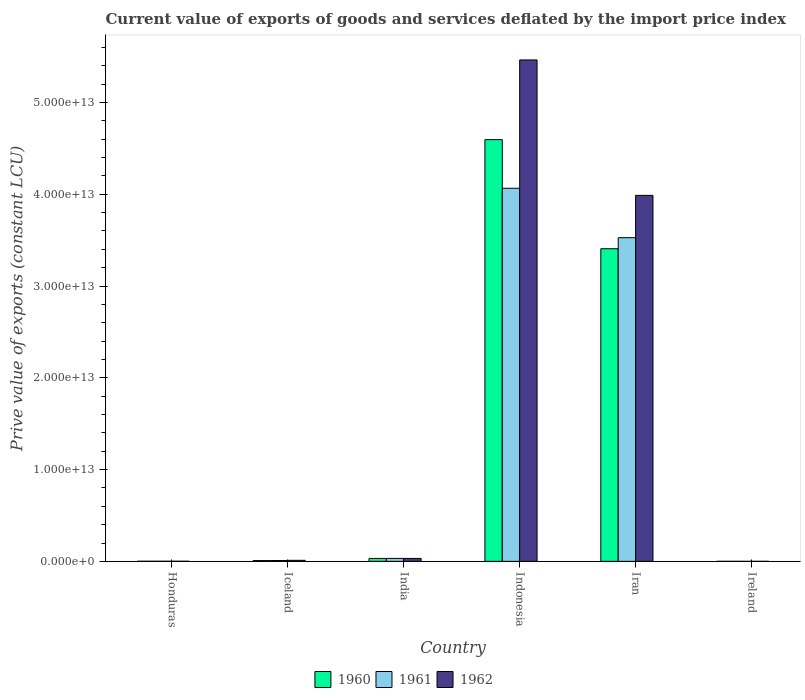How many bars are there on the 6th tick from the left?
Ensure brevity in your answer.  3. In how many cases, is the number of bars for a given country not equal to the number of legend labels?
Offer a very short reply. 0. What is the prive value of exports in 1960 in Iran?
Give a very brief answer. 3.41e+13. Across all countries, what is the maximum prive value of exports in 1962?
Offer a terse response. 5.46e+13. Across all countries, what is the minimum prive value of exports in 1960?
Provide a short and direct response. 2.78e+09. In which country was the prive value of exports in 1961 maximum?
Your answer should be compact. Indonesia. In which country was the prive value of exports in 1961 minimum?
Offer a very short reply. Ireland. What is the total prive value of exports in 1962 in the graph?
Offer a very short reply. 9.50e+13. What is the difference between the prive value of exports in 1960 in Honduras and that in Ireland?
Offer a very short reply. 7.89e+09. What is the difference between the prive value of exports in 1960 in Iceland and the prive value of exports in 1962 in Ireland?
Your response must be concise. 8.28e+1. What is the average prive value of exports in 1962 per country?
Offer a very short reply. 1.58e+13. What is the difference between the prive value of exports of/in 1960 and prive value of exports of/in 1961 in Honduras?
Your answer should be compact. -1.27e+09. In how many countries, is the prive value of exports in 1960 greater than 28000000000000 LCU?
Ensure brevity in your answer.  2. What is the ratio of the prive value of exports in 1962 in Iceland to that in Iran?
Make the answer very short. 0. Is the difference between the prive value of exports in 1960 in Honduras and Iceland greater than the difference between the prive value of exports in 1961 in Honduras and Iceland?
Keep it short and to the point. Yes. What is the difference between the highest and the second highest prive value of exports in 1961?
Make the answer very short. 4.03e+13. What is the difference between the highest and the lowest prive value of exports in 1962?
Make the answer very short. 5.46e+13. What does the 3rd bar from the right in Ireland represents?
Provide a succinct answer. 1960. How many bars are there?
Provide a succinct answer. 18. What is the difference between two consecutive major ticks on the Y-axis?
Keep it short and to the point. 1.00e+13. Are the values on the major ticks of Y-axis written in scientific E-notation?
Ensure brevity in your answer.  Yes. Does the graph contain any zero values?
Your response must be concise. No. How many legend labels are there?
Your answer should be compact. 3. How are the legend labels stacked?
Offer a very short reply. Horizontal. What is the title of the graph?
Offer a terse response. Current value of exports of goods and services deflated by the import price index. Does "1998" appear as one of the legend labels in the graph?
Offer a very short reply. No. What is the label or title of the X-axis?
Your response must be concise. Country. What is the label or title of the Y-axis?
Your answer should be compact. Prive value of exports (constant LCU). What is the Prive value of exports (constant LCU) in 1960 in Honduras?
Your answer should be very brief. 1.07e+1. What is the Prive value of exports (constant LCU) of 1961 in Honduras?
Give a very brief answer. 1.19e+1. What is the Prive value of exports (constant LCU) of 1962 in Honduras?
Make the answer very short. 1.31e+1. What is the Prive value of exports (constant LCU) in 1960 in Iceland?
Offer a terse response. 8.60e+1. What is the Prive value of exports (constant LCU) of 1961 in Iceland?
Offer a very short reply. 9.34e+1. What is the Prive value of exports (constant LCU) in 1962 in Iceland?
Offer a very short reply. 1.12e+11. What is the Prive value of exports (constant LCU) in 1960 in India?
Provide a short and direct response. 3.21e+11. What is the Prive value of exports (constant LCU) of 1961 in India?
Keep it short and to the point. 3.20e+11. What is the Prive value of exports (constant LCU) of 1962 in India?
Your answer should be compact. 3.19e+11. What is the Prive value of exports (constant LCU) in 1960 in Indonesia?
Offer a terse response. 4.60e+13. What is the Prive value of exports (constant LCU) in 1961 in Indonesia?
Offer a very short reply. 4.07e+13. What is the Prive value of exports (constant LCU) of 1962 in Indonesia?
Your answer should be very brief. 5.46e+13. What is the Prive value of exports (constant LCU) in 1960 in Iran?
Your answer should be very brief. 3.41e+13. What is the Prive value of exports (constant LCU) of 1961 in Iran?
Offer a terse response. 3.53e+13. What is the Prive value of exports (constant LCU) in 1962 in Iran?
Provide a short and direct response. 3.99e+13. What is the Prive value of exports (constant LCU) of 1960 in Ireland?
Keep it short and to the point. 2.78e+09. What is the Prive value of exports (constant LCU) of 1961 in Ireland?
Make the answer very short. 3.22e+09. What is the Prive value of exports (constant LCU) of 1962 in Ireland?
Offer a very short reply. 3.23e+09. Across all countries, what is the maximum Prive value of exports (constant LCU) in 1960?
Your answer should be compact. 4.60e+13. Across all countries, what is the maximum Prive value of exports (constant LCU) of 1961?
Offer a very short reply. 4.07e+13. Across all countries, what is the maximum Prive value of exports (constant LCU) in 1962?
Ensure brevity in your answer.  5.46e+13. Across all countries, what is the minimum Prive value of exports (constant LCU) of 1960?
Offer a terse response. 2.78e+09. Across all countries, what is the minimum Prive value of exports (constant LCU) of 1961?
Offer a terse response. 3.22e+09. Across all countries, what is the minimum Prive value of exports (constant LCU) in 1962?
Ensure brevity in your answer.  3.23e+09. What is the total Prive value of exports (constant LCU) in 1960 in the graph?
Your answer should be very brief. 8.04e+13. What is the total Prive value of exports (constant LCU) of 1961 in the graph?
Provide a succinct answer. 7.63e+13. What is the total Prive value of exports (constant LCU) in 1962 in the graph?
Your response must be concise. 9.50e+13. What is the difference between the Prive value of exports (constant LCU) of 1960 in Honduras and that in Iceland?
Provide a succinct answer. -7.54e+1. What is the difference between the Prive value of exports (constant LCU) of 1961 in Honduras and that in Iceland?
Your answer should be very brief. -8.14e+1. What is the difference between the Prive value of exports (constant LCU) of 1962 in Honduras and that in Iceland?
Your answer should be very brief. -9.94e+1. What is the difference between the Prive value of exports (constant LCU) of 1960 in Honduras and that in India?
Provide a short and direct response. -3.10e+11. What is the difference between the Prive value of exports (constant LCU) of 1961 in Honduras and that in India?
Provide a succinct answer. -3.08e+11. What is the difference between the Prive value of exports (constant LCU) of 1962 in Honduras and that in India?
Your answer should be very brief. -3.05e+11. What is the difference between the Prive value of exports (constant LCU) of 1960 in Honduras and that in Indonesia?
Your response must be concise. -4.59e+13. What is the difference between the Prive value of exports (constant LCU) of 1961 in Honduras and that in Indonesia?
Offer a terse response. -4.06e+13. What is the difference between the Prive value of exports (constant LCU) of 1962 in Honduras and that in Indonesia?
Provide a short and direct response. -5.46e+13. What is the difference between the Prive value of exports (constant LCU) of 1960 in Honduras and that in Iran?
Make the answer very short. -3.41e+13. What is the difference between the Prive value of exports (constant LCU) in 1961 in Honduras and that in Iran?
Your answer should be compact. -3.53e+13. What is the difference between the Prive value of exports (constant LCU) of 1962 in Honduras and that in Iran?
Give a very brief answer. -3.99e+13. What is the difference between the Prive value of exports (constant LCU) of 1960 in Honduras and that in Ireland?
Give a very brief answer. 7.89e+09. What is the difference between the Prive value of exports (constant LCU) of 1961 in Honduras and that in Ireland?
Keep it short and to the point. 8.72e+09. What is the difference between the Prive value of exports (constant LCU) of 1962 in Honduras and that in Ireland?
Provide a succinct answer. 9.87e+09. What is the difference between the Prive value of exports (constant LCU) of 1960 in Iceland and that in India?
Provide a succinct answer. -2.35e+11. What is the difference between the Prive value of exports (constant LCU) of 1961 in Iceland and that in India?
Provide a short and direct response. -2.27e+11. What is the difference between the Prive value of exports (constant LCU) of 1962 in Iceland and that in India?
Provide a short and direct response. -2.06e+11. What is the difference between the Prive value of exports (constant LCU) in 1960 in Iceland and that in Indonesia?
Provide a succinct answer. -4.59e+13. What is the difference between the Prive value of exports (constant LCU) in 1961 in Iceland and that in Indonesia?
Offer a terse response. -4.06e+13. What is the difference between the Prive value of exports (constant LCU) in 1962 in Iceland and that in Indonesia?
Keep it short and to the point. -5.45e+13. What is the difference between the Prive value of exports (constant LCU) in 1960 in Iceland and that in Iran?
Provide a short and direct response. -3.40e+13. What is the difference between the Prive value of exports (constant LCU) of 1961 in Iceland and that in Iran?
Give a very brief answer. -3.52e+13. What is the difference between the Prive value of exports (constant LCU) of 1962 in Iceland and that in Iran?
Make the answer very short. -3.98e+13. What is the difference between the Prive value of exports (constant LCU) in 1960 in Iceland and that in Ireland?
Give a very brief answer. 8.33e+1. What is the difference between the Prive value of exports (constant LCU) of 1961 in Iceland and that in Ireland?
Keep it short and to the point. 9.02e+1. What is the difference between the Prive value of exports (constant LCU) in 1962 in Iceland and that in Ireland?
Provide a short and direct response. 1.09e+11. What is the difference between the Prive value of exports (constant LCU) in 1960 in India and that in Indonesia?
Keep it short and to the point. -4.56e+13. What is the difference between the Prive value of exports (constant LCU) in 1961 in India and that in Indonesia?
Ensure brevity in your answer.  -4.03e+13. What is the difference between the Prive value of exports (constant LCU) in 1962 in India and that in Indonesia?
Offer a terse response. -5.43e+13. What is the difference between the Prive value of exports (constant LCU) in 1960 in India and that in Iran?
Keep it short and to the point. -3.37e+13. What is the difference between the Prive value of exports (constant LCU) of 1961 in India and that in Iran?
Provide a short and direct response. -3.49e+13. What is the difference between the Prive value of exports (constant LCU) of 1962 in India and that in Iran?
Your answer should be very brief. -3.96e+13. What is the difference between the Prive value of exports (constant LCU) of 1960 in India and that in Ireland?
Provide a short and direct response. 3.18e+11. What is the difference between the Prive value of exports (constant LCU) of 1961 in India and that in Ireland?
Your answer should be very brief. 3.17e+11. What is the difference between the Prive value of exports (constant LCU) in 1962 in India and that in Ireland?
Provide a short and direct response. 3.15e+11. What is the difference between the Prive value of exports (constant LCU) in 1960 in Indonesia and that in Iran?
Keep it short and to the point. 1.19e+13. What is the difference between the Prive value of exports (constant LCU) of 1961 in Indonesia and that in Iran?
Ensure brevity in your answer.  5.38e+12. What is the difference between the Prive value of exports (constant LCU) of 1962 in Indonesia and that in Iran?
Make the answer very short. 1.48e+13. What is the difference between the Prive value of exports (constant LCU) in 1960 in Indonesia and that in Ireland?
Give a very brief answer. 4.59e+13. What is the difference between the Prive value of exports (constant LCU) of 1961 in Indonesia and that in Ireland?
Your answer should be very brief. 4.06e+13. What is the difference between the Prive value of exports (constant LCU) of 1962 in Indonesia and that in Ireland?
Your response must be concise. 5.46e+13. What is the difference between the Prive value of exports (constant LCU) of 1960 in Iran and that in Ireland?
Offer a very short reply. 3.41e+13. What is the difference between the Prive value of exports (constant LCU) in 1961 in Iran and that in Ireland?
Provide a succinct answer. 3.53e+13. What is the difference between the Prive value of exports (constant LCU) of 1962 in Iran and that in Ireland?
Give a very brief answer. 3.99e+13. What is the difference between the Prive value of exports (constant LCU) in 1960 in Honduras and the Prive value of exports (constant LCU) in 1961 in Iceland?
Your answer should be compact. -8.27e+1. What is the difference between the Prive value of exports (constant LCU) in 1960 in Honduras and the Prive value of exports (constant LCU) in 1962 in Iceland?
Give a very brief answer. -1.02e+11. What is the difference between the Prive value of exports (constant LCU) of 1961 in Honduras and the Prive value of exports (constant LCU) of 1962 in Iceland?
Your answer should be very brief. -1.01e+11. What is the difference between the Prive value of exports (constant LCU) in 1960 in Honduras and the Prive value of exports (constant LCU) in 1961 in India?
Offer a very short reply. -3.10e+11. What is the difference between the Prive value of exports (constant LCU) of 1960 in Honduras and the Prive value of exports (constant LCU) of 1962 in India?
Give a very brief answer. -3.08e+11. What is the difference between the Prive value of exports (constant LCU) in 1961 in Honduras and the Prive value of exports (constant LCU) in 1962 in India?
Keep it short and to the point. -3.07e+11. What is the difference between the Prive value of exports (constant LCU) of 1960 in Honduras and the Prive value of exports (constant LCU) of 1961 in Indonesia?
Your answer should be very brief. -4.06e+13. What is the difference between the Prive value of exports (constant LCU) of 1960 in Honduras and the Prive value of exports (constant LCU) of 1962 in Indonesia?
Ensure brevity in your answer.  -5.46e+13. What is the difference between the Prive value of exports (constant LCU) in 1961 in Honduras and the Prive value of exports (constant LCU) in 1962 in Indonesia?
Give a very brief answer. -5.46e+13. What is the difference between the Prive value of exports (constant LCU) in 1960 in Honduras and the Prive value of exports (constant LCU) in 1961 in Iran?
Give a very brief answer. -3.53e+13. What is the difference between the Prive value of exports (constant LCU) in 1960 in Honduras and the Prive value of exports (constant LCU) in 1962 in Iran?
Give a very brief answer. -3.99e+13. What is the difference between the Prive value of exports (constant LCU) of 1961 in Honduras and the Prive value of exports (constant LCU) of 1962 in Iran?
Provide a succinct answer. -3.99e+13. What is the difference between the Prive value of exports (constant LCU) in 1960 in Honduras and the Prive value of exports (constant LCU) in 1961 in Ireland?
Give a very brief answer. 7.45e+09. What is the difference between the Prive value of exports (constant LCU) in 1960 in Honduras and the Prive value of exports (constant LCU) in 1962 in Ireland?
Offer a terse response. 7.44e+09. What is the difference between the Prive value of exports (constant LCU) in 1961 in Honduras and the Prive value of exports (constant LCU) in 1962 in Ireland?
Keep it short and to the point. 8.71e+09. What is the difference between the Prive value of exports (constant LCU) of 1960 in Iceland and the Prive value of exports (constant LCU) of 1961 in India?
Make the answer very short. -2.34e+11. What is the difference between the Prive value of exports (constant LCU) of 1960 in Iceland and the Prive value of exports (constant LCU) of 1962 in India?
Ensure brevity in your answer.  -2.32e+11. What is the difference between the Prive value of exports (constant LCU) in 1961 in Iceland and the Prive value of exports (constant LCU) in 1962 in India?
Keep it short and to the point. -2.25e+11. What is the difference between the Prive value of exports (constant LCU) in 1960 in Iceland and the Prive value of exports (constant LCU) in 1961 in Indonesia?
Give a very brief answer. -4.06e+13. What is the difference between the Prive value of exports (constant LCU) of 1960 in Iceland and the Prive value of exports (constant LCU) of 1962 in Indonesia?
Ensure brevity in your answer.  -5.45e+13. What is the difference between the Prive value of exports (constant LCU) of 1961 in Iceland and the Prive value of exports (constant LCU) of 1962 in Indonesia?
Ensure brevity in your answer.  -5.45e+13. What is the difference between the Prive value of exports (constant LCU) in 1960 in Iceland and the Prive value of exports (constant LCU) in 1961 in Iran?
Offer a terse response. -3.52e+13. What is the difference between the Prive value of exports (constant LCU) of 1960 in Iceland and the Prive value of exports (constant LCU) of 1962 in Iran?
Provide a short and direct response. -3.98e+13. What is the difference between the Prive value of exports (constant LCU) of 1961 in Iceland and the Prive value of exports (constant LCU) of 1962 in Iran?
Give a very brief answer. -3.98e+13. What is the difference between the Prive value of exports (constant LCU) of 1960 in Iceland and the Prive value of exports (constant LCU) of 1961 in Ireland?
Your response must be concise. 8.28e+1. What is the difference between the Prive value of exports (constant LCU) of 1960 in Iceland and the Prive value of exports (constant LCU) of 1962 in Ireland?
Your answer should be very brief. 8.28e+1. What is the difference between the Prive value of exports (constant LCU) of 1961 in Iceland and the Prive value of exports (constant LCU) of 1962 in Ireland?
Ensure brevity in your answer.  9.02e+1. What is the difference between the Prive value of exports (constant LCU) of 1960 in India and the Prive value of exports (constant LCU) of 1961 in Indonesia?
Offer a very short reply. -4.03e+13. What is the difference between the Prive value of exports (constant LCU) in 1960 in India and the Prive value of exports (constant LCU) in 1962 in Indonesia?
Make the answer very short. -5.43e+13. What is the difference between the Prive value of exports (constant LCU) of 1961 in India and the Prive value of exports (constant LCU) of 1962 in Indonesia?
Your answer should be compact. -5.43e+13. What is the difference between the Prive value of exports (constant LCU) of 1960 in India and the Prive value of exports (constant LCU) of 1961 in Iran?
Make the answer very short. -3.49e+13. What is the difference between the Prive value of exports (constant LCU) of 1960 in India and the Prive value of exports (constant LCU) of 1962 in Iran?
Your response must be concise. -3.96e+13. What is the difference between the Prive value of exports (constant LCU) in 1961 in India and the Prive value of exports (constant LCU) in 1962 in Iran?
Your response must be concise. -3.96e+13. What is the difference between the Prive value of exports (constant LCU) in 1960 in India and the Prive value of exports (constant LCU) in 1961 in Ireland?
Your response must be concise. 3.18e+11. What is the difference between the Prive value of exports (constant LCU) in 1960 in India and the Prive value of exports (constant LCU) in 1962 in Ireland?
Keep it short and to the point. 3.18e+11. What is the difference between the Prive value of exports (constant LCU) in 1961 in India and the Prive value of exports (constant LCU) in 1962 in Ireland?
Keep it short and to the point. 3.17e+11. What is the difference between the Prive value of exports (constant LCU) of 1960 in Indonesia and the Prive value of exports (constant LCU) of 1961 in Iran?
Ensure brevity in your answer.  1.07e+13. What is the difference between the Prive value of exports (constant LCU) in 1960 in Indonesia and the Prive value of exports (constant LCU) in 1962 in Iran?
Keep it short and to the point. 6.07e+12. What is the difference between the Prive value of exports (constant LCU) in 1961 in Indonesia and the Prive value of exports (constant LCU) in 1962 in Iran?
Give a very brief answer. 7.73e+11. What is the difference between the Prive value of exports (constant LCU) of 1960 in Indonesia and the Prive value of exports (constant LCU) of 1961 in Ireland?
Your answer should be very brief. 4.59e+13. What is the difference between the Prive value of exports (constant LCU) of 1960 in Indonesia and the Prive value of exports (constant LCU) of 1962 in Ireland?
Keep it short and to the point. 4.59e+13. What is the difference between the Prive value of exports (constant LCU) in 1961 in Indonesia and the Prive value of exports (constant LCU) in 1962 in Ireland?
Your response must be concise. 4.06e+13. What is the difference between the Prive value of exports (constant LCU) of 1960 in Iran and the Prive value of exports (constant LCU) of 1961 in Ireland?
Ensure brevity in your answer.  3.41e+13. What is the difference between the Prive value of exports (constant LCU) in 1960 in Iran and the Prive value of exports (constant LCU) in 1962 in Ireland?
Keep it short and to the point. 3.41e+13. What is the difference between the Prive value of exports (constant LCU) of 1961 in Iran and the Prive value of exports (constant LCU) of 1962 in Ireland?
Give a very brief answer. 3.53e+13. What is the average Prive value of exports (constant LCU) in 1960 per country?
Give a very brief answer. 1.34e+13. What is the average Prive value of exports (constant LCU) of 1961 per country?
Offer a terse response. 1.27e+13. What is the average Prive value of exports (constant LCU) in 1962 per country?
Give a very brief answer. 1.58e+13. What is the difference between the Prive value of exports (constant LCU) of 1960 and Prive value of exports (constant LCU) of 1961 in Honduras?
Provide a succinct answer. -1.27e+09. What is the difference between the Prive value of exports (constant LCU) of 1960 and Prive value of exports (constant LCU) of 1962 in Honduras?
Your answer should be compact. -2.43e+09. What is the difference between the Prive value of exports (constant LCU) in 1961 and Prive value of exports (constant LCU) in 1962 in Honduras?
Offer a terse response. -1.15e+09. What is the difference between the Prive value of exports (constant LCU) of 1960 and Prive value of exports (constant LCU) of 1961 in Iceland?
Keep it short and to the point. -7.34e+09. What is the difference between the Prive value of exports (constant LCU) in 1960 and Prive value of exports (constant LCU) in 1962 in Iceland?
Your answer should be very brief. -2.64e+1. What is the difference between the Prive value of exports (constant LCU) of 1961 and Prive value of exports (constant LCU) of 1962 in Iceland?
Make the answer very short. -1.91e+1. What is the difference between the Prive value of exports (constant LCU) of 1960 and Prive value of exports (constant LCU) of 1961 in India?
Ensure brevity in your answer.  5.97e+08. What is the difference between the Prive value of exports (constant LCU) of 1960 and Prive value of exports (constant LCU) of 1962 in India?
Keep it short and to the point. 2.45e+09. What is the difference between the Prive value of exports (constant LCU) of 1961 and Prive value of exports (constant LCU) of 1962 in India?
Provide a short and direct response. 1.86e+09. What is the difference between the Prive value of exports (constant LCU) of 1960 and Prive value of exports (constant LCU) of 1961 in Indonesia?
Your answer should be compact. 5.30e+12. What is the difference between the Prive value of exports (constant LCU) in 1960 and Prive value of exports (constant LCU) in 1962 in Indonesia?
Your response must be concise. -8.68e+12. What is the difference between the Prive value of exports (constant LCU) in 1961 and Prive value of exports (constant LCU) in 1962 in Indonesia?
Make the answer very short. -1.40e+13. What is the difference between the Prive value of exports (constant LCU) of 1960 and Prive value of exports (constant LCU) of 1961 in Iran?
Provide a short and direct response. -1.21e+12. What is the difference between the Prive value of exports (constant LCU) of 1960 and Prive value of exports (constant LCU) of 1962 in Iran?
Your response must be concise. -5.81e+12. What is the difference between the Prive value of exports (constant LCU) of 1961 and Prive value of exports (constant LCU) of 1962 in Iran?
Keep it short and to the point. -4.61e+12. What is the difference between the Prive value of exports (constant LCU) of 1960 and Prive value of exports (constant LCU) of 1961 in Ireland?
Give a very brief answer. -4.39e+08. What is the difference between the Prive value of exports (constant LCU) of 1960 and Prive value of exports (constant LCU) of 1962 in Ireland?
Provide a succinct answer. -4.49e+08. What is the difference between the Prive value of exports (constant LCU) in 1961 and Prive value of exports (constant LCU) in 1962 in Ireland?
Your answer should be compact. -9.94e+06. What is the ratio of the Prive value of exports (constant LCU) in 1960 in Honduras to that in Iceland?
Provide a short and direct response. 0.12. What is the ratio of the Prive value of exports (constant LCU) of 1961 in Honduras to that in Iceland?
Provide a succinct answer. 0.13. What is the ratio of the Prive value of exports (constant LCU) in 1962 in Honduras to that in Iceland?
Give a very brief answer. 0.12. What is the ratio of the Prive value of exports (constant LCU) of 1960 in Honduras to that in India?
Your response must be concise. 0.03. What is the ratio of the Prive value of exports (constant LCU) of 1961 in Honduras to that in India?
Provide a succinct answer. 0.04. What is the ratio of the Prive value of exports (constant LCU) of 1962 in Honduras to that in India?
Give a very brief answer. 0.04. What is the ratio of the Prive value of exports (constant LCU) of 1960 in Honduras to that in Indonesia?
Provide a succinct answer. 0. What is the ratio of the Prive value of exports (constant LCU) in 1960 in Honduras to that in Iran?
Ensure brevity in your answer.  0. What is the ratio of the Prive value of exports (constant LCU) of 1960 in Honduras to that in Ireland?
Offer a terse response. 3.84. What is the ratio of the Prive value of exports (constant LCU) in 1961 in Honduras to that in Ireland?
Offer a terse response. 3.71. What is the ratio of the Prive value of exports (constant LCU) of 1962 in Honduras to that in Ireland?
Provide a succinct answer. 4.06. What is the ratio of the Prive value of exports (constant LCU) in 1960 in Iceland to that in India?
Offer a very short reply. 0.27. What is the ratio of the Prive value of exports (constant LCU) in 1961 in Iceland to that in India?
Keep it short and to the point. 0.29. What is the ratio of the Prive value of exports (constant LCU) in 1962 in Iceland to that in India?
Provide a short and direct response. 0.35. What is the ratio of the Prive value of exports (constant LCU) in 1960 in Iceland to that in Indonesia?
Keep it short and to the point. 0. What is the ratio of the Prive value of exports (constant LCU) in 1961 in Iceland to that in Indonesia?
Provide a succinct answer. 0. What is the ratio of the Prive value of exports (constant LCU) of 1962 in Iceland to that in Indonesia?
Offer a terse response. 0. What is the ratio of the Prive value of exports (constant LCU) of 1960 in Iceland to that in Iran?
Ensure brevity in your answer.  0. What is the ratio of the Prive value of exports (constant LCU) of 1961 in Iceland to that in Iran?
Your answer should be very brief. 0. What is the ratio of the Prive value of exports (constant LCU) of 1962 in Iceland to that in Iran?
Make the answer very short. 0. What is the ratio of the Prive value of exports (constant LCU) of 1960 in Iceland to that in Ireland?
Your answer should be compact. 30.98. What is the ratio of the Prive value of exports (constant LCU) of 1961 in Iceland to that in Ireland?
Your answer should be compact. 29.03. What is the ratio of the Prive value of exports (constant LCU) in 1962 in Iceland to that in Ireland?
Provide a succinct answer. 34.86. What is the ratio of the Prive value of exports (constant LCU) in 1960 in India to that in Indonesia?
Make the answer very short. 0.01. What is the ratio of the Prive value of exports (constant LCU) of 1961 in India to that in Indonesia?
Give a very brief answer. 0.01. What is the ratio of the Prive value of exports (constant LCU) of 1962 in India to that in Indonesia?
Offer a terse response. 0.01. What is the ratio of the Prive value of exports (constant LCU) in 1960 in India to that in Iran?
Give a very brief answer. 0.01. What is the ratio of the Prive value of exports (constant LCU) of 1961 in India to that in Iran?
Give a very brief answer. 0.01. What is the ratio of the Prive value of exports (constant LCU) in 1962 in India to that in Iran?
Offer a terse response. 0.01. What is the ratio of the Prive value of exports (constant LCU) of 1960 in India to that in Ireland?
Offer a very short reply. 115.58. What is the ratio of the Prive value of exports (constant LCU) of 1961 in India to that in Ireland?
Offer a very short reply. 99.61. What is the ratio of the Prive value of exports (constant LCU) in 1962 in India to that in Ireland?
Keep it short and to the point. 98.73. What is the ratio of the Prive value of exports (constant LCU) in 1960 in Indonesia to that in Iran?
Ensure brevity in your answer.  1.35. What is the ratio of the Prive value of exports (constant LCU) of 1961 in Indonesia to that in Iran?
Your answer should be compact. 1.15. What is the ratio of the Prive value of exports (constant LCU) of 1962 in Indonesia to that in Iran?
Give a very brief answer. 1.37. What is the ratio of the Prive value of exports (constant LCU) of 1960 in Indonesia to that in Ireland?
Ensure brevity in your answer.  1.65e+04. What is the ratio of the Prive value of exports (constant LCU) in 1961 in Indonesia to that in Ireland?
Keep it short and to the point. 1.26e+04. What is the ratio of the Prive value of exports (constant LCU) in 1962 in Indonesia to that in Ireland?
Your answer should be compact. 1.69e+04. What is the ratio of the Prive value of exports (constant LCU) of 1960 in Iran to that in Ireland?
Your response must be concise. 1.23e+04. What is the ratio of the Prive value of exports (constant LCU) of 1961 in Iran to that in Ireland?
Offer a very short reply. 1.10e+04. What is the ratio of the Prive value of exports (constant LCU) in 1962 in Iran to that in Ireland?
Your answer should be compact. 1.24e+04. What is the difference between the highest and the second highest Prive value of exports (constant LCU) in 1960?
Your response must be concise. 1.19e+13. What is the difference between the highest and the second highest Prive value of exports (constant LCU) in 1961?
Ensure brevity in your answer.  5.38e+12. What is the difference between the highest and the second highest Prive value of exports (constant LCU) in 1962?
Offer a terse response. 1.48e+13. What is the difference between the highest and the lowest Prive value of exports (constant LCU) of 1960?
Provide a succinct answer. 4.59e+13. What is the difference between the highest and the lowest Prive value of exports (constant LCU) of 1961?
Ensure brevity in your answer.  4.06e+13. What is the difference between the highest and the lowest Prive value of exports (constant LCU) of 1962?
Your answer should be compact. 5.46e+13. 